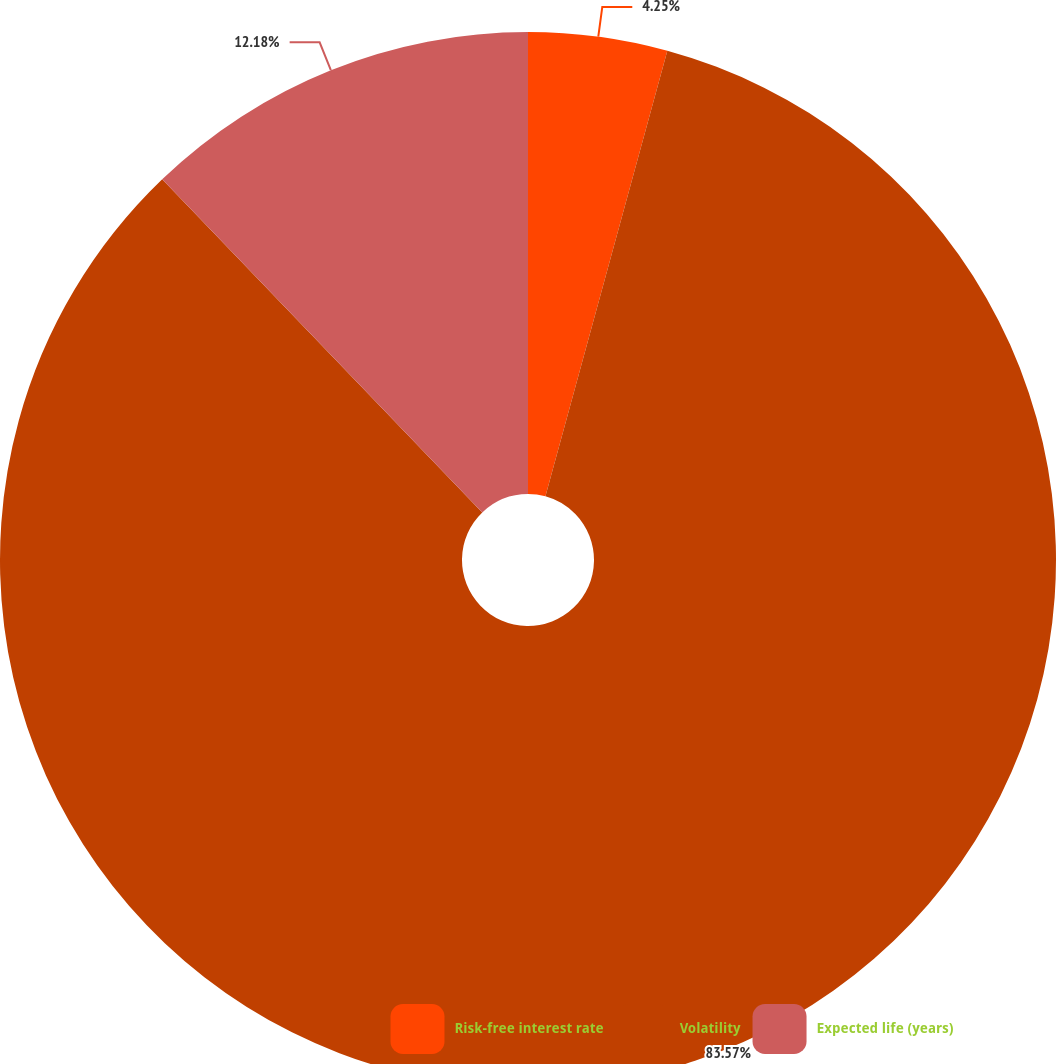Convert chart to OTSL. <chart><loc_0><loc_0><loc_500><loc_500><pie_chart><fcel>Risk-free interest rate<fcel>Volatility<fcel>Expected life (years)<nl><fcel>4.25%<fcel>83.56%<fcel>12.18%<nl></chart> 